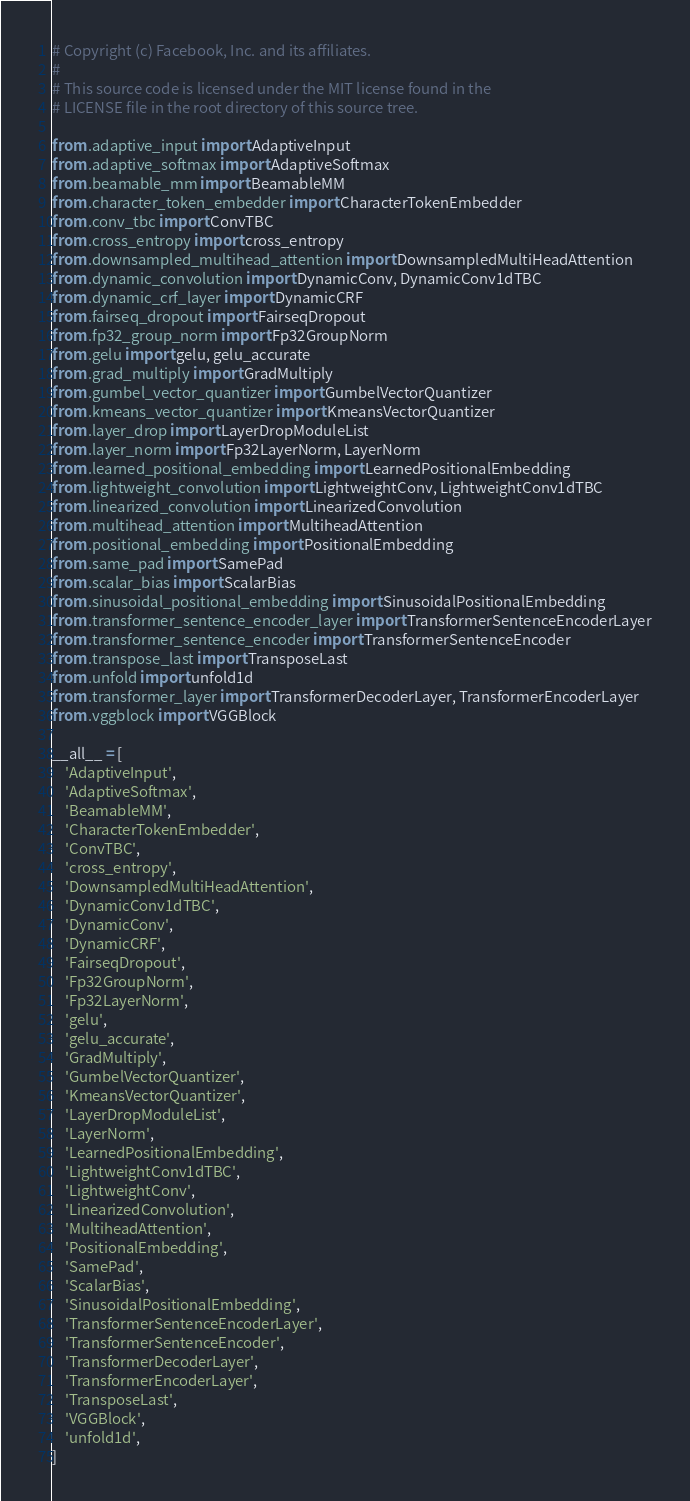Convert code to text. <code><loc_0><loc_0><loc_500><loc_500><_Python_># Copyright (c) Facebook, Inc. and its affiliates.
#
# This source code is licensed under the MIT license found in the
# LICENSE file in the root directory of this source tree.

from .adaptive_input import AdaptiveInput
from .adaptive_softmax import AdaptiveSoftmax
from .beamable_mm import BeamableMM
from .character_token_embedder import CharacterTokenEmbedder
from .conv_tbc import ConvTBC
from .cross_entropy import cross_entropy
from .downsampled_multihead_attention import DownsampledMultiHeadAttention
from .dynamic_convolution import DynamicConv, DynamicConv1dTBC
from .dynamic_crf_layer import DynamicCRF
from .fairseq_dropout import FairseqDropout
from .fp32_group_norm import Fp32GroupNorm
from .gelu import gelu, gelu_accurate
from .grad_multiply import GradMultiply
from .gumbel_vector_quantizer import GumbelVectorQuantizer
from .kmeans_vector_quantizer import KmeansVectorQuantizer
from .layer_drop import LayerDropModuleList
from .layer_norm import Fp32LayerNorm, LayerNorm
from .learned_positional_embedding import LearnedPositionalEmbedding
from .lightweight_convolution import LightweightConv, LightweightConv1dTBC
from .linearized_convolution import LinearizedConvolution
from .multihead_attention import MultiheadAttention
from .positional_embedding import PositionalEmbedding
from .same_pad import SamePad
from .scalar_bias import ScalarBias
from .sinusoidal_positional_embedding import SinusoidalPositionalEmbedding
from .transformer_sentence_encoder_layer import TransformerSentenceEncoderLayer
from .transformer_sentence_encoder import TransformerSentenceEncoder
from .transpose_last import TransposeLast
from .unfold import unfold1d
from .transformer_layer import TransformerDecoderLayer, TransformerEncoderLayer
from .vggblock import VGGBlock

__all__ = [
    'AdaptiveInput',
    'AdaptiveSoftmax',
    'BeamableMM',
    'CharacterTokenEmbedder',
    'ConvTBC',
    'cross_entropy',
    'DownsampledMultiHeadAttention',
    'DynamicConv1dTBC',
    'DynamicConv',
    'DynamicCRF',
    'FairseqDropout',
    'Fp32GroupNorm',
    'Fp32LayerNorm',
    'gelu',
    'gelu_accurate',
    'GradMultiply',
    'GumbelVectorQuantizer',
    'KmeansVectorQuantizer',
    'LayerDropModuleList',
    'LayerNorm',
    'LearnedPositionalEmbedding',
    'LightweightConv1dTBC',
    'LightweightConv',
    'LinearizedConvolution',
    'MultiheadAttention',
    'PositionalEmbedding',
    'SamePad',
    'ScalarBias',
    'SinusoidalPositionalEmbedding',
    'TransformerSentenceEncoderLayer',
    'TransformerSentenceEncoder',
    'TransformerDecoderLayer',
    'TransformerEncoderLayer',
    'TransposeLast',
    'VGGBlock',
    'unfold1d',
]
</code> 